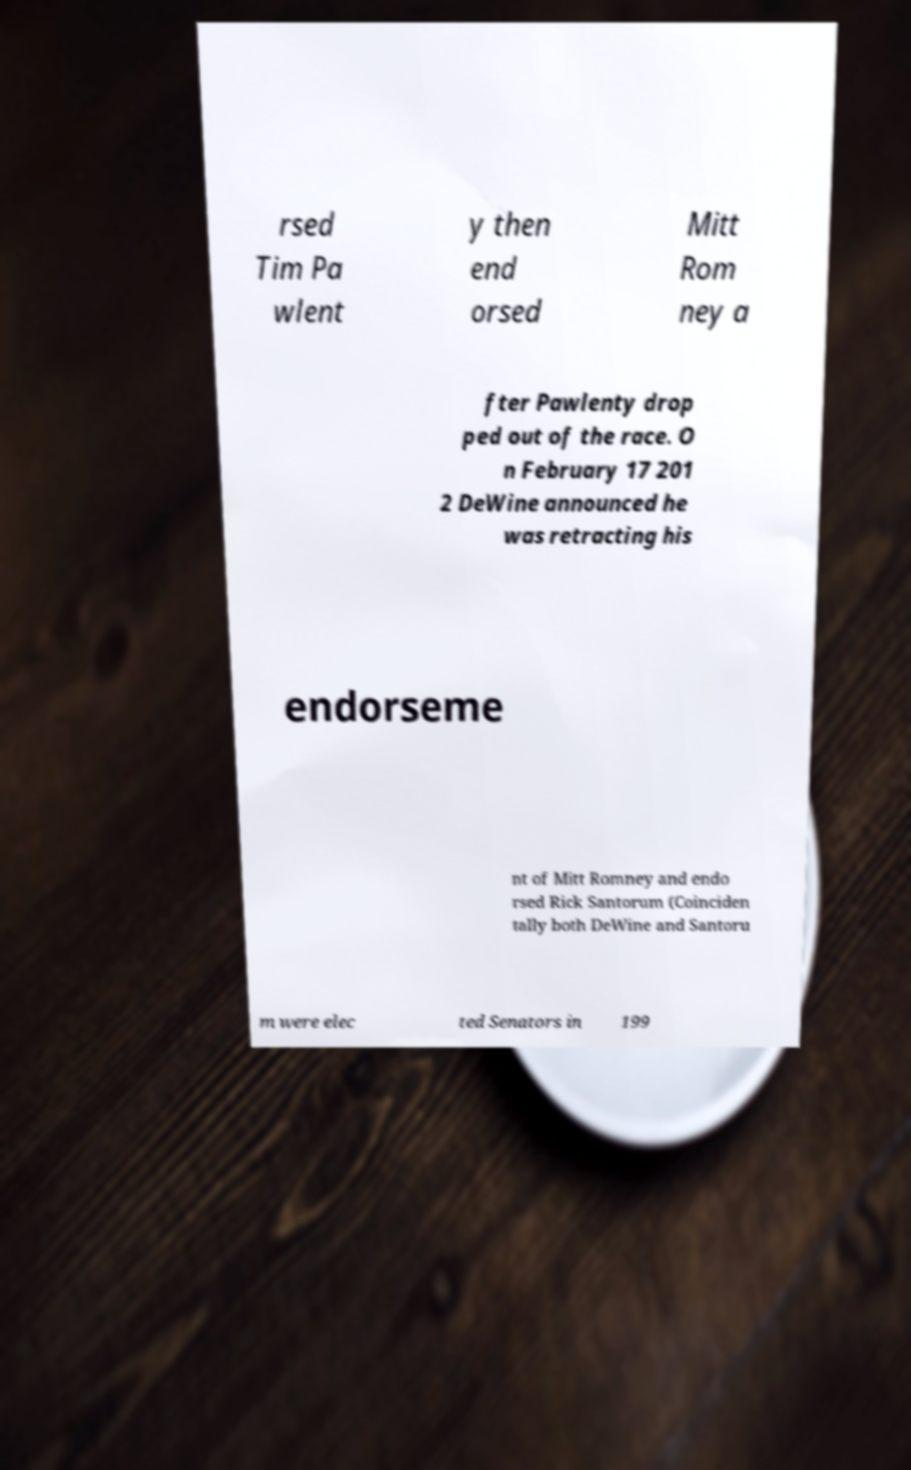Can you read and provide the text displayed in the image?This photo seems to have some interesting text. Can you extract and type it out for me? rsed Tim Pa wlent y then end orsed Mitt Rom ney a fter Pawlenty drop ped out of the race. O n February 17 201 2 DeWine announced he was retracting his endorseme nt of Mitt Romney and endo rsed Rick Santorum (Coinciden tally both DeWine and Santoru m were elec ted Senators in 199 